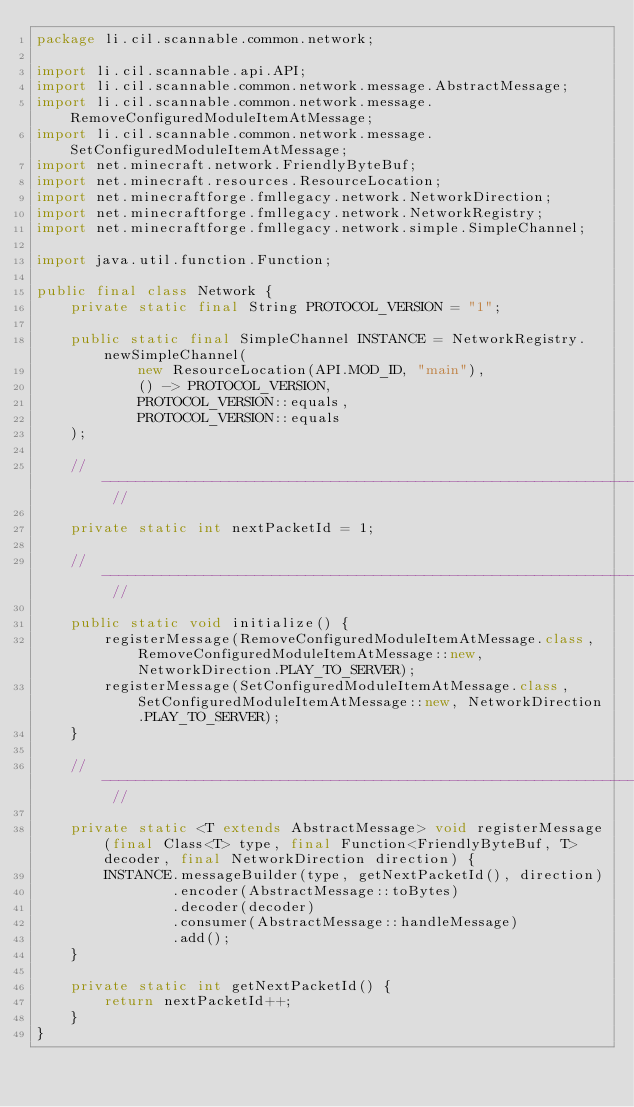Convert code to text. <code><loc_0><loc_0><loc_500><loc_500><_Java_>package li.cil.scannable.common.network;

import li.cil.scannable.api.API;
import li.cil.scannable.common.network.message.AbstractMessage;
import li.cil.scannable.common.network.message.RemoveConfiguredModuleItemAtMessage;
import li.cil.scannable.common.network.message.SetConfiguredModuleItemAtMessage;
import net.minecraft.network.FriendlyByteBuf;
import net.minecraft.resources.ResourceLocation;
import net.minecraftforge.fmllegacy.network.NetworkDirection;
import net.minecraftforge.fmllegacy.network.NetworkRegistry;
import net.minecraftforge.fmllegacy.network.simple.SimpleChannel;

import java.util.function.Function;

public final class Network {
    private static final String PROTOCOL_VERSION = "1";

    public static final SimpleChannel INSTANCE = NetworkRegistry.newSimpleChannel(
            new ResourceLocation(API.MOD_ID, "main"),
            () -> PROTOCOL_VERSION,
            PROTOCOL_VERSION::equals,
            PROTOCOL_VERSION::equals
    );

    // --------------------------------------------------------------------- //

    private static int nextPacketId = 1;

    // --------------------------------------------------------------------- //

    public static void initialize() {
        registerMessage(RemoveConfiguredModuleItemAtMessage.class, RemoveConfiguredModuleItemAtMessage::new, NetworkDirection.PLAY_TO_SERVER);
        registerMessage(SetConfiguredModuleItemAtMessage.class, SetConfiguredModuleItemAtMessage::new, NetworkDirection.PLAY_TO_SERVER);
    }

    // --------------------------------------------------------------------- //

    private static <T extends AbstractMessage> void registerMessage(final Class<T> type, final Function<FriendlyByteBuf, T> decoder, final NetworkDirection direction) {
        INSTANCE.messageBuilder(type, getNextPacketId(), direction)
                .encoder(AbstractMessage::toBytes)
                .decoder(decoder)
                .consumer(AbstractMessage::handleMessage)
                .add();
    }

    private static int getNextPacketId() {
        return nextPacketId++;
    }
}
</code> 